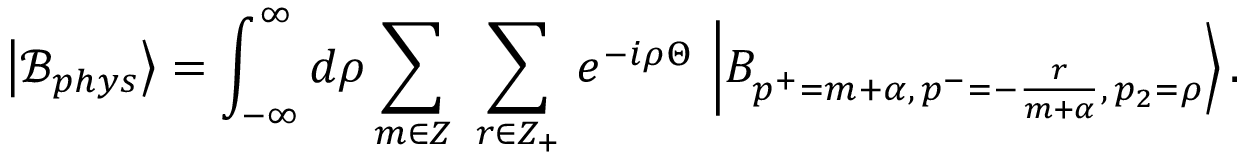Convert formula to latex. <formula><loc_0><loc_0><loc_500><loc_500>\left | \mathcal { B } _ { p h y s } \right \rangle = \int _ { - \infty } ^ { \infty } d \rho \sum _ { m \in Z } \ \sum _ { r \in Z _ { + } } \, e ^ { - i \rho \Theta } \, \left | B _ { p ^ { + } = m + \alpha , \, p ^ { - } = - \frac { r } { m + \alpha } , \, p _ { 2 } = \rho } \right \rangle .</formula> 